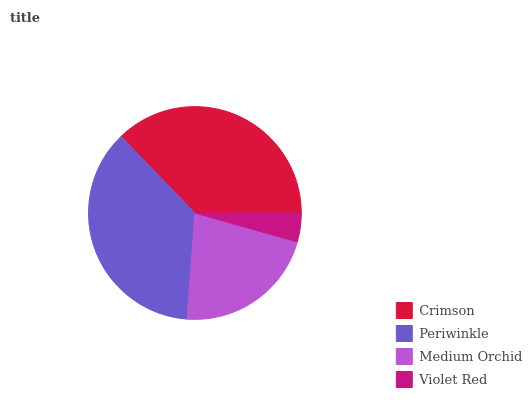Is Violet Red the minimum?
Answer yes or no. Yes. Is Crimson the maximum?
Answer yes or no. Yes. Is Periwinkle the minimum?
Answer yes or no. No. Is Periwinkle the maximum?
Answer yes or no. No. Is Crimson greater than Periwinkle?
Answer yes or no. Yes. Is Periwinkle less than Crimson?
Answer yes or no. Yes. Is Periwinkle greater than Crimson?
Answer yes or no. No. Is Crimson less than Periwinkle?
Answer yes or no. No. Is Periwinkle the high median?
Answer yes or no. Yes. Is Medium Orchid the low median?
Answer yes or no. Yes. Is Violet Red the high median?
Answer yes or no. No. Is Crimson the low median?
Answer yes or no. No. 